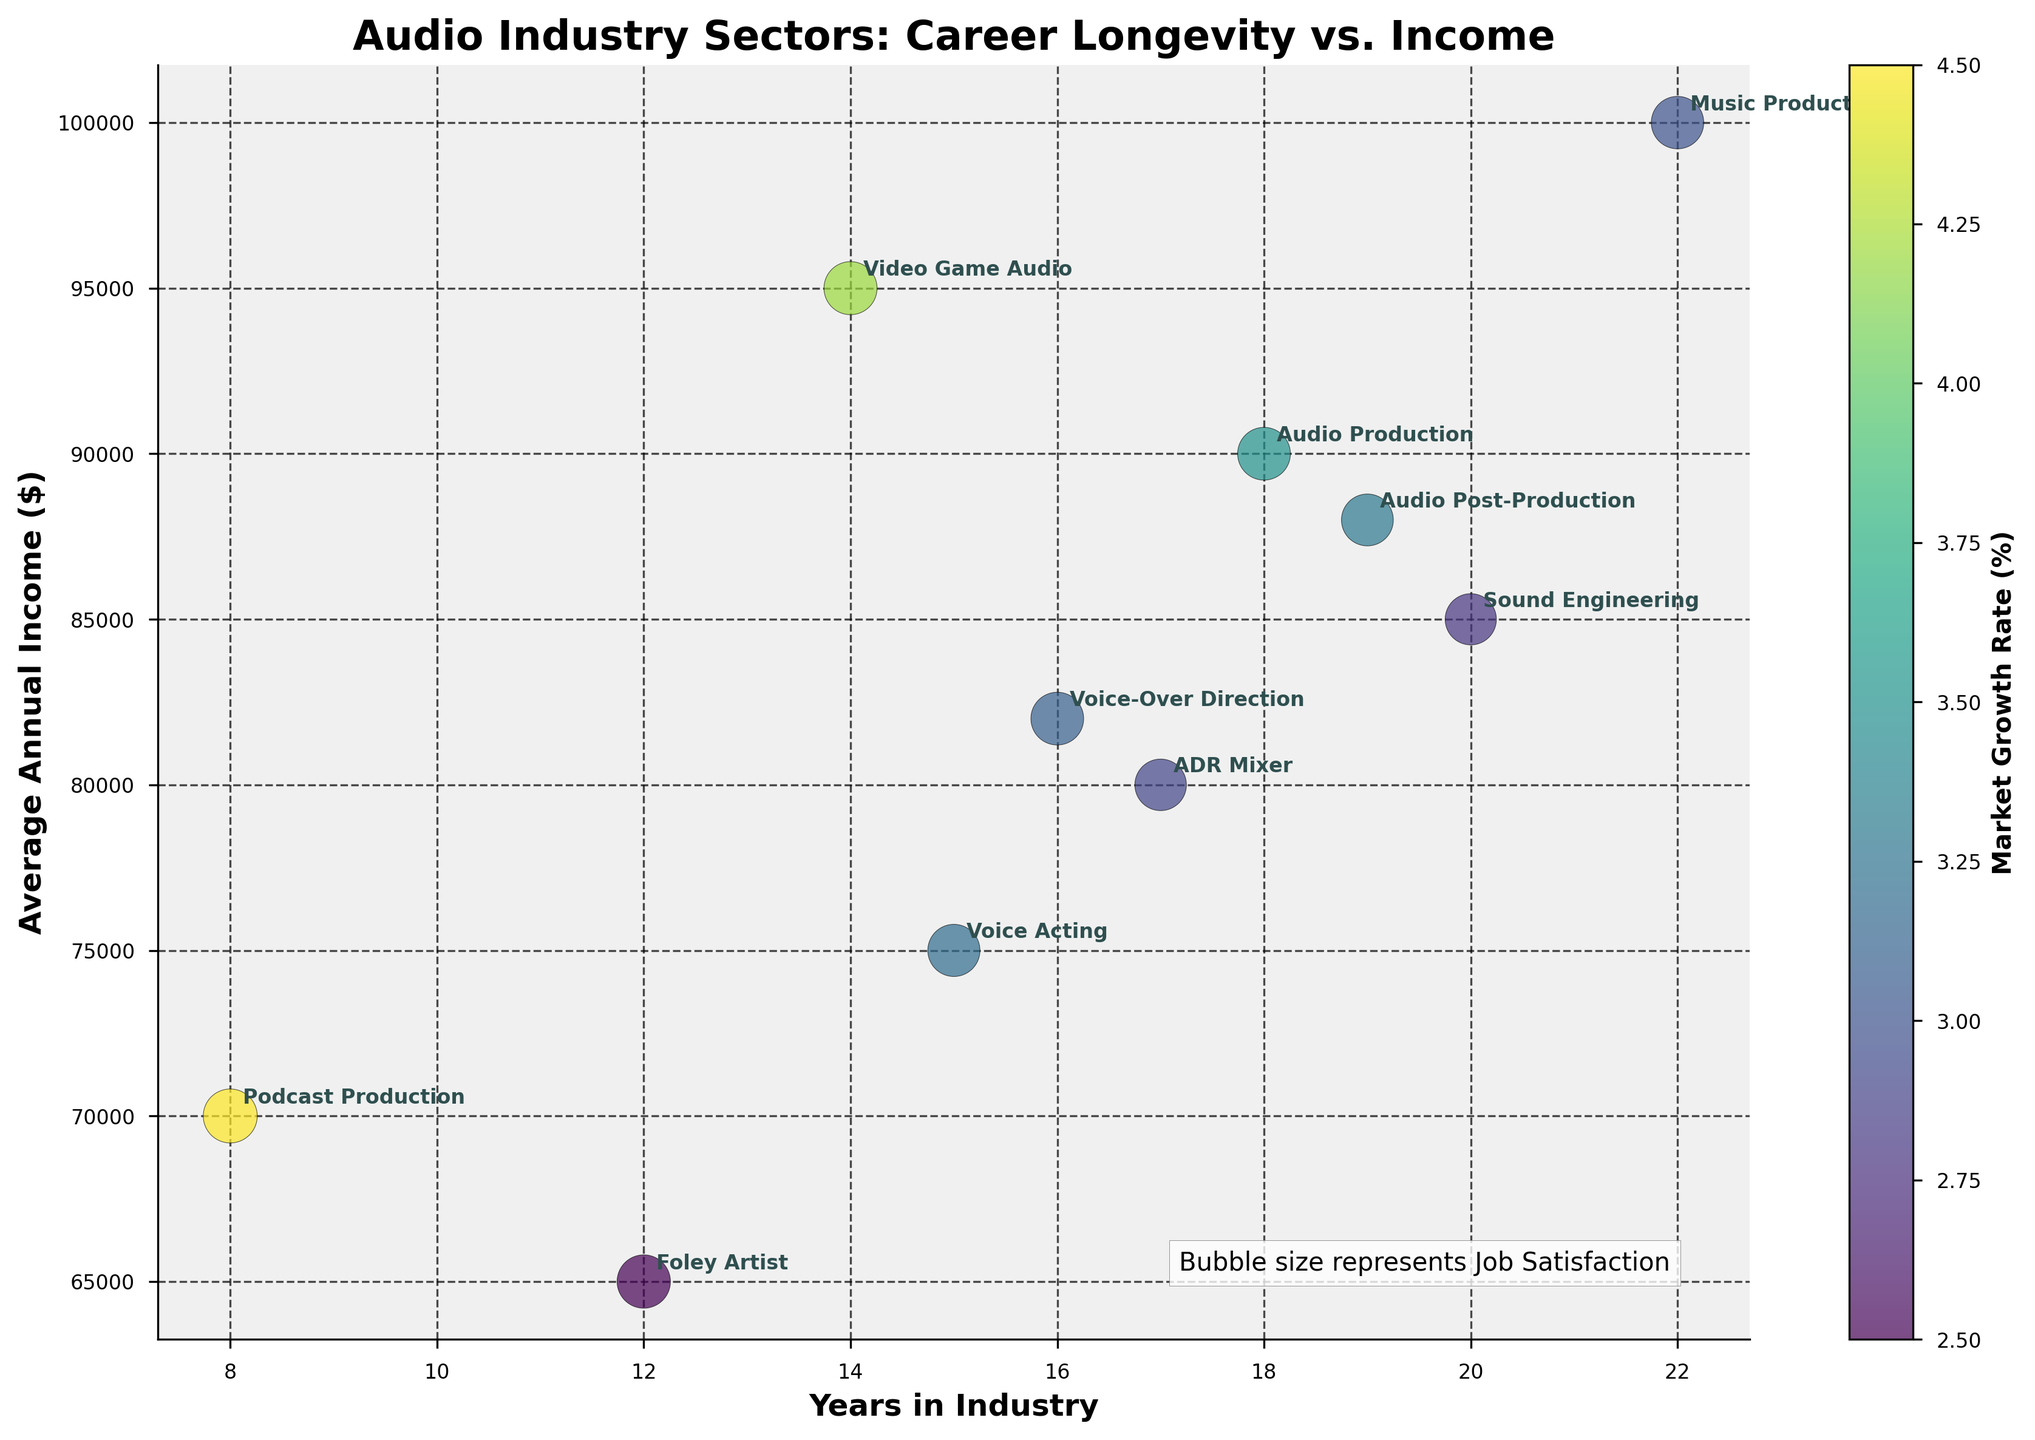What is the title of the plot? The title of the plot is displayed at the top center of the figure. It reads "Audio Industry Sectors: Career Longevity vs. Income".
Answer: Audio Industry Sectors: Career Longevity vs. Income Which sector has the highest average annual income? Look for the highest point on the y-axis, which represents the Average Annual Income. The sector associated with this point is Music Production.
Answer: Music Production What is the market growth rate color-coding for the sector Podcast Production? Find the bubble labeled "Podcast Production" and notice its color. Referring to the color bar on the side, this color signifies a market growth rate of 4.5%.
Answer: 4.5% Which sector has the largest bubble size and what does it represent? The large bubble size is influenced by Job Satisfaction. The largest bubble size corresponds to Podcast Production, indicating it has the highest Job Satisfaction score of 9.1.
Answer: Podcast Production How many sectors are represented in the plot? Count the number of distinct sectors mentioned in the data or check the labeled bubbles in the plot. There are 10 sectors in total.
Answer: 10 Which sector has the lowest years in the industry, and what is its average annual income? Identify the bubble closest to the origin on the x-axis, which represents Years in Industry. This sector is "Podcast Production," with an average annual income of $70,000.
Answer: Podcast Production, $70,000 Compare the job satisfaction of Voice Acting and Audio Post-Production sectors. Which has higher satisfaction? Note the sizes of both bubbles, as they represent Job Satisfaction. Voice Acting has a Job Satisfaction score of 8.5, while Audio Post-Production is 8.4.
Answer: Voice Acting Which sector shows the highest market growth rate? Refer to the color bar and identify the darkest color bubble, indicating the highest market growth rate. This sector is "Podcast Production" with a 4.5% growth rate.
Answer: Podcast Production Between Sound Engineering and Audio Production, which one has a higher average annual income, and by how much? Locate the respective bubbles and compare their y-axis positions. Audio Production ($90,000) has a higher income than Sound Engineering ($85,000) by $5,000.
Answer: Audio Production, $5,000 